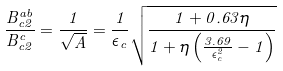<formula> <loc_0><loc_0><loc_500><loc_500>\frac { B _ { c 2 } ^ { a b } } { B _ { c 2 } ^ { c } } = \frac { 1 } { \sqrt { A } } = \frac { 1 } { \epsilon _ { c } } \sqrt { \frac { 1 + 0 . 6 3 \eta } { 1 + \eta \left ( \frac { 3 . 6 9 } { \epsilon _ { c } ^ { 2 } } - 1 \right ) } }</formula> 